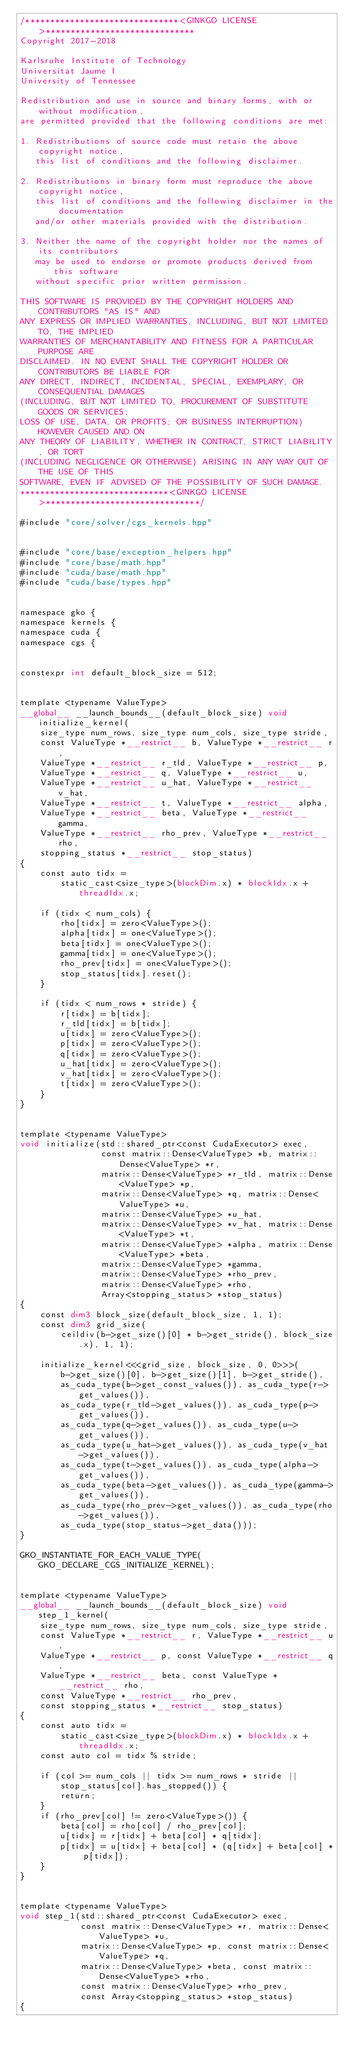Convert code to text. <code><loc_0><loc_0><loc_500><loc_500><_Cuda_>/*******************************<GINKGO LICENSE>******************************
Copyright 2017-2018

Karlsruhe Institute of Technology
Universitat Jaume I
University of Tennessee

Redistribution and use in source and binary forms, with or without modification,
are permitted provided that the following conditions are met:

1. Redistributions of source code must retain the above copyright notice,
   this list of conditions and the following disclaimer.

2. Redistributions in binary form must reproduce the above copyright notice,
   this list of conditions and the following disclaimer in the documentation
   and/or other materials provided with the distribution.

3. Neither the name of the copyright holder nor the names of its contributors
   may be used to endorse or promote products derived from this software
   without specific prior written permission.

THIS SOFTWARE IS PROVIDED BY THE COPYRIGHT HOLDERS AND CONTRIBUTORS "AS IS" AND
ANY EXPRESS OR IMPLIED WARRANTIES, INCLUDING, BUT NOT LIMITED TO, THE IMPLIED
WARRANTIES OF MERCHANTABILITY AND FITNESS FOR A PARTICULAR PURPOSE ARE
DISCLAIMED. IN NO EVENT SHALL THE COPYRIGHT HOLDER OR CONTRIBUTORS BE LIABLE FOR
ANY DIRECT, INDIRECT, INCIDENTAL, SPECIAL, EXEMPLARY, OR CONSEQUENTIAL DAMAGES
(INCLUDING, BUT NOT LIMITED TO, PROCUREMENT OF SUBSTITUTE GOODS OR SERVICES;
LOSS OF USE, DATA, OR PROFITS; OR BUSINESS INTERRUPTION) HOWEVER CAUSED AND ON
ANY THEORY OF LIABILITY, WHETHER IN CONTRACT, STRICT LIABILITY, OR TORT
(INCLUDING NEGLIGENCE OR OTHERWISE) ARISING IN ANY WAY OUT OF THE USE OF THIS
SOFTWARE, EVEN IF ADVISED OF THE POSSIBILITY OF SUCH DAMAGE.
******************************<GINKGO LICENSE>*******************************/

#include "core/solver/cgs_kernels.hpp"


#include "core/base/exception_helpers.hpp"
#include "core/base/math.hpp"
#include "cuda/base/math.hpp"
#include "cuda/base/types.hpp"


namespace gko {
namespace kernels {
namespace cuda {
namespace cgs {


constexpr int default_block_size = 512;


template <typename ValueType>
__global__ __launch_bounds__(default_block_size) void initialize_kernel(
    size_type num_rows, size_type num_cols, size_type stride,
    const ValueType *__restrict__ b, ValueType *__restrict__ r,
    ValueType *__restrict__ r_tld, ValueType *__restrict__ p,
    ValueType *__restrict__ q, ValueType *__restrict__ u,
    ValueType *__restrict__ u_hat, ValueType *__restrict__ v_hat,
    ValueType *__restrict__ t, ValueType *__restrict__ alpha,
    ValueType *__restrict__ beta, ValueType *__restrict__ gamma,
    ValueType *__restrict__ rho_prev, ValueType *__restrict__ rho,
    stopping_status *__restrict__ stop_status)
{
    const auto tidx =
        static_cast<size_type>(blockDim.x) * blockIdx.x + threadIdx.x;

    if (tidx < num_cols) {
        rho[tidx] = zero<ValueType>();
        alpha[tidx] = one<ValueType>();
        beta[tidx] = one<ValueType>();
        gamma[tidx] = one<ValueType>();
        rho_prev[tidx] = one<ValueType>();
        stop_status[tidx].reset();
    }

    if (tidx < num_rows * stride) {
        r[tidx] = b[tidx];
        r_tld[tidx] = b[tidx];
        u[tidx] = zero<ValueType>();
        p[tidx] = zero<ValueType>();
        q[tidx] = zero<ValueType>();
        u_hat[tidx] = zero<ValueType>();
        v_hat[tidx] = zero<ValueType>();
        t[tidx] = zero<ValueType>();
    }
}


template <typename ValueType>
void initialize(std::shared_ptr<const CudaExecutor> exec,
                const matrix::Dense<ValueType> *b, matrix::Dense<ValueType> *r,
                matrix::Dense<ValueType> *r_tld, matrix::Dense<ValueType> *p,
                matrix::Dense<ValueType> *q, matrix::Dense<ValueType> *u,
                matrix::Dense<ValueType> *u_hat,
                matrix::Dense<ValueType> *v_hat, matrix::Dense<ValueType> *t,
                matrix::Dense<ValueType> *alpha, matrix::Dense<ValueType> *beta,
                matrix::Dense<ValueType> *gamma,
                matrix::Dense<ValueType> *rho_prev,
                matrix::Dense<ValueType> *rho,
                Array<stopping_status> *stop_status)
{
    const dim3 block_size(default_block_size, 1, 1);
    const dim3 grid_size(
        ceildiv(b->get_size()[0] * b->get_stride(), block_size.x), 1, 1);

    initialize_kernel<<<grid_size, block_size, 0, 0>>>(
        b->get_size()[0], b->get_size()[1], b->get_stride(),
        as_cuda_type(b->get_const_values()), as_cuda_type(r->get_values()),
        as_cuda_type(r_tld->get_values()), as_cuda_type(p->get_values()),
        as_cuda_type(q->get_values()), as_cuda_type(u->get_values()),
        as_cuda_type(u_hat->get_values()), as_cuda_type(v_hat->get_values()),
        as_cuda_type(t->get_values()), as_cuda_type(alpha->get_values()),
        as_cuda_type(beta->get_values()), as_cuda_type(gamma->get_values()),
        as_cuda_type(rho_prev->get_values()), as_cuda_type(rho->get_values()),
        as_cuda_type(stop_status->get_data()));
}

GKO_INSTANTIATE_FOR_EACH_VALUE_TYPE(GKO_DECLARE_CGS_INITIALIZE_KERNEL);


template <typename ValueType>
__global__ __launch_bounds__(default_block_size) void step_1_kernel(
    size_type num_rows, size_type num_cols, size_type stride,
    const ValueType *__restrict__ r, ValueType *__restrict__ u,
    ValueType *__restrict__ p, const ValueType *__restrict__ q,
    ValueType *__restrict__ beta, const ValueType *__restrict__ rho,
    const ValueType *__restrict__ rho_prev,
    const stopping_status *__restrict__ stop_status)
{
    const auto tidx =
        static_cast<size_type>(blockDim.x) * blockIdx.x + threadIdx.x;
    const auto col = tidx % stride;

    if (col >= num_cols || tidx >= num_rows * stride ||
        stop_status[col].has_stopped()) {
        return;
    }
    if (rho_prev[col] != zero<ValueType>()) {
        beta[col] = rho[col] / rho_prev[col];
        u[tidx] = r[tidx] + beta[col] * q[tidx];
        p[tidx] = u[tidx] + beta[col] * (q[tidx] + beta[col] * p[tidx]);
    }
}


template <typename ValueType>
void step_1(std::shared_ptr<const CudaExecutor> exec,
            const matrix::Dense<ValueType> *r, matrix::Dense<ValueType> *u,
            matrix::Dense<ValueType> *p, const matrix::Dense<ValueType> *q,
            matrix::Dense<ValueType> *beta, const matrix::Dense<ValueType> *rho,
            const matrix::Dense<ValueType> *rho_prev,
            const Array<stopping_status> *stop_status)
{</code> 